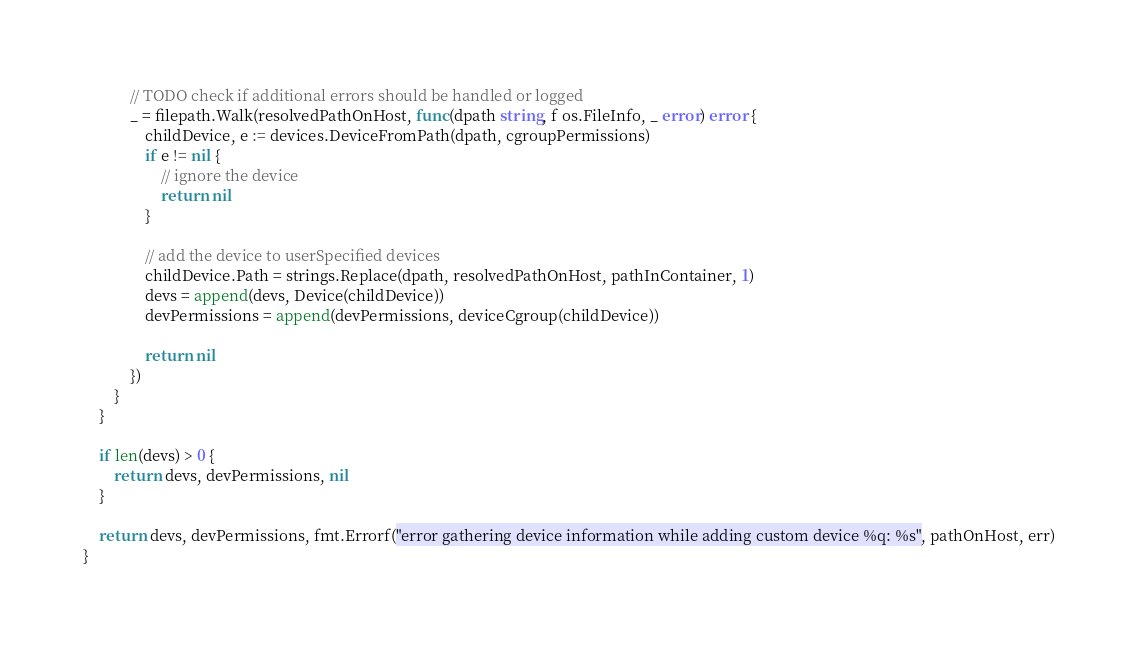<code> <loc_0><loc_0><loc_500><loc_500><_Go_>			// TODO check if additional errors should be handled or logged
			_ = filepath.Walk(resolvedPathOnHost, func(dpath string, f os.FileInfo, _ error) error {
				childDevice, e := devices.DeviceFromPath(dpath, cgroupPermissions)
				if e != nil {
					// ignore the device
					return nil
				}

				// add the device to userSpecified devices
				childDevice.Path = strings.Replace(dpath, resolvedPathOnHost, pathInContainer, 1)
				devs = append(devs, Device(childDevice))
				devPermissions = append(devPermissions, deviceCgroup(childDevice))

				return nil
			})
		}
	}

	if len(devs) > 0 {
		return devs, devPermissions, nil
	}

	return devs, devPermissions, fmt.Errorf("error gathering device information while adding custom device %q: %s", pathOnHost, err)
}
</code> 